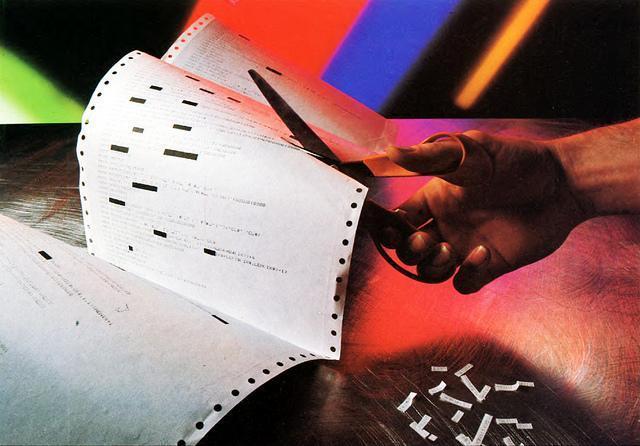How many books are visible?
Give a very brief answer. 2. How many cars are in the image?
Give a very brief answer. 0. 